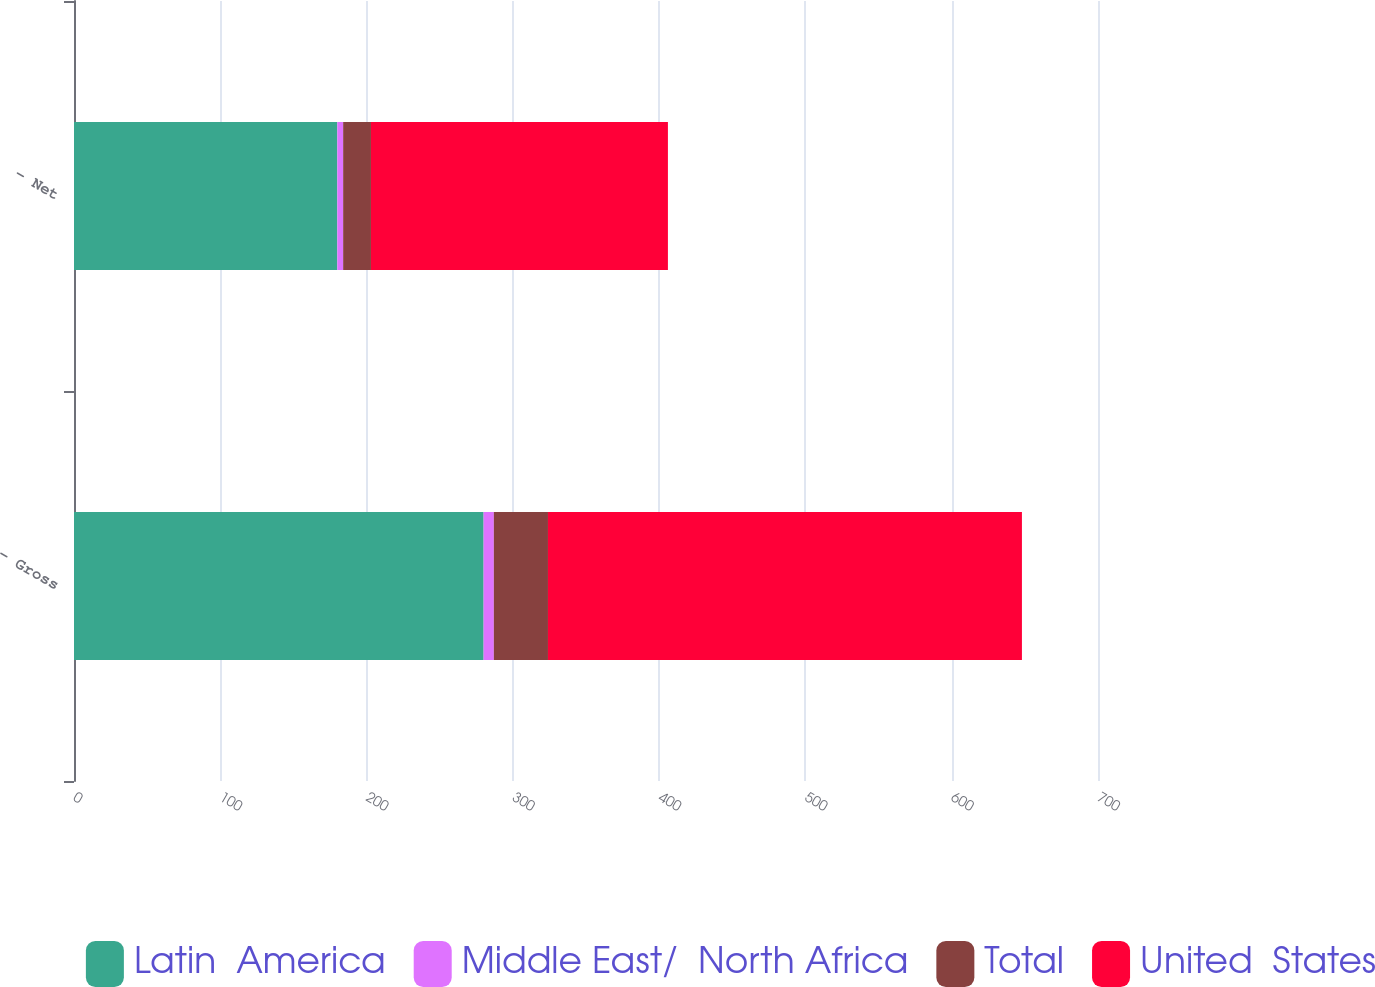Convert chart. <chart><loc_0><loc_0><loc_500><loc_500><stacked_bar_chart><ecel><fcel>- Gross<fcel>- Net<nl><fcel>Latin  America<fcel>280<fcel>180<nl><fcel>Middle East/  North Africa<fcel>7<fcel>4<nl><fcel>Total<fcel>37<fcel>19<nl><fcel>United  States<fcel>324<fcel>203<nl></chart> 